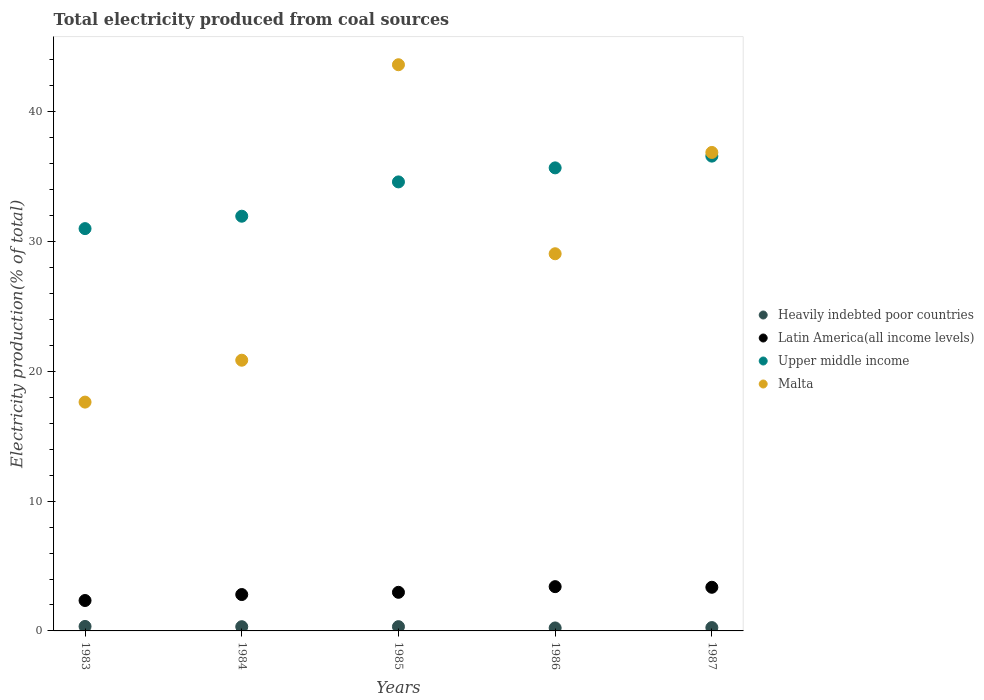Is the number of dotlines equal to the number of legend labels?
Keep it short and to the point. Yes. What is the total electricity produced in Latin America(all income levels) in 1984?
Provide a short and direct response. 2.8. Across all years, what is the maximum total electricity produced in Malta?
Keep it short and to the point. 43.62. Across all years, what is the minimum total electricity produced in Upper middle income?
Provide a short and direct response. 31. In which year was the total electricity produced in Heavily indebted poor countries minimum?
Give a very brief answer. 1986. What is the total total electricity produced in Latin America(all income levels) in the graph?
Ensure brevity in your answer.  14.9. What is the difference between the total electricity produced in Malta in 1984 and that in 1987?
Make the answer very short. -16.01. What is the difference between the total electricity produced in Malta in 1983 and the total electricity produced in Heavily indebted poor countries in 1986?
Make the answer very short. 17.4. What is the average total electricity produced in Malta per year?
Offer a very short reply. 29.61. In the year 1987, what is the difference between the total electricity produced in Upper middle income and total electricity produced in Heavily indebted poor countries?
Make the answer very short. 36.32. What is the ratio of the total electricity produced in Heavily indebted poor countries in 1983 to that in 1987?
Offer a very short reply. 1.34. What is the difference between the highest and the second highest total electricity produced in Latin America(all income levels)?
Your response must be concise. 0.05. What is the difference between the highest and the lowest total electricity produced in Latin America(all income levels)?
Ensure brevity in your answer.  1.07. In how many years, is the total electricity produced in Heavily indebted poor countries greater than the average total electricity produced in Heavily indebted poor countries taken over all years?
Provide a succinct answer. 3. Is the sum of the total electricity produced in Upper middle income in 1983 and 1986 greater than the maximum total electricity produced in Malta across all years?
Ensure brevity in your answer.  Yes. Is it the case that in every year, the sum of the total electricity produced in Latin America(all income levels) and total electricity produced in Upper middle income  is greater than the sum of total electricity produced in Heavily indebted poor countries and total electricity produced in Malta?
Make the answer very short. Yes. Is it the case that in every year, the sum of the total electricity produced in Upper middle income and total electricity produced in Heavily indebted poor countries  is greater than the total electricity produced in Malta?
Provide a succinct answer. No. Does the total electricity produced in Heavily indebted poor countries monotonically increase over the years?
Your answer should be very brief. No. How many dotlines are there?
Make the answer very short. 4. Are the values on the major ticks of Y-axis written in scientific E-notation?
Your answer should be compact. No. Does the graph contain grids?
Give a very brief answer. No. How many legend labels are there?
Make the answer very short. 4. What is the title of the graph?
Your answer should be compact. Total electricity produced from coal sources. Does "Korea (Democratic)" appear as one of the legend labels in the graph?
Offer a very short reply. No. What is the Electricity production(% of total) in Heavily indebted poor countries in 1983?
Your answer should be very brief. 0.34. What is the Electricity production(% of total) of Latin America(all income levels) in 1983?
Ensure brevity in your answer.  2.34. What is the Electricity production(% of total) of Upper middle income in 1983?
Offer a very short reply. 31. What is the Electricity production(% of total) of Malta in 1983?
Ensure brevity in your answer.  17.63. What is the Electricity production(% of total) of Heavily indebted poor countries in 1984?
Your answer should be compact. 0.33. What is the Electricity production(% of total) of Latin America(all income levels) in 1984?
Keep it short and to the point. 2.8. What is the Electricity production(% of total) in Upper middle income in 1984?
Give a very brief answer. 31.95. What is the Electricity production(% of total) in Malta in 1984?
Offer a very short reply. 20.86. What is the Electricity production(% of total) in Heavily indebted poor countries in 1985?
Offer a terse response. 0.33. What is the Electricity production(% of total) in Latin America(all income levels) in 1985?
Your answer should be very brief. 2.97. What is the Electricity production(% of total) in Upper middle income in 1985?
Make the answer very short. 34.6. What is the Electricity production(% of total) in Malta in 1985?
Offer a terse response. 43.62. What is the Electricity production(% of total) in Heavily indebted poor countries in 1986?
Make the answer very short. 0.23. What is the Electricity production(% of total) in Latin America(all income levels) in 1986?
Make the answer very short. 3.41. What is the Electricity production(% of total) in Upper middle income in 1986?
Your answer should be very brief. 35.68. What is the Electricity production(% of total) in Malta in 1986?
Make the answer very short. 29.06. What is the Electricity production(% of total) of Heavily indebted poor countries in 1987?
Offer a terse response. 0.26. What is the Electricity production(% of total) in Latin America(all income levels) in 1987?
Provide a short and direct response. 3.36. What is the Electricity production(% of total) of Upper middle income in 1987?
Offer a very short reply. 36.58. What is the Electricity production(% of total) of Malta in 1987?
Ensure brevity in your answer.  36.86. Across all years, what is the maximum Electricity production(% of total) in Heavily indebted poor countries?
Provide a succinct answer. 0.34. Across all years, what is the maximum Electricity production(% of total) of Latin America(all income levels)?
Your answer should be very brief. 3.41. Across all years, what is the maximum Electricity production(% of total) in Upper middle income?
Offer a terse response. 36.58. Across all years, what is the maximum Electricity production(% of total) in Malta?
Offer a terse response. 43.62. Across all years, what is the minimum Electricity production(% of total) of Heavily indebted poor countries?
Provide a succinct answer. 0.23. Across all years, what is the minimum Electricity production(% of total) in Latin America(all income levels)?
Your response must be concise. 2.34. Across all years, what is the minimum Electricity production(% of total) in Upper middle income?
Provide a short and direct response. 31. Across all years, what is the minimum Electricity production(% of total) in Malta?
Offer a very short reply. 17.63. What is the total Electricity production(% of total) of Heavily indebted poor countries in the graph?
Your answer should be compact. 1.49. What is the total Electricity production(% of total) in Latin America(all income levels) in the graph?
Provide a succinct answer. 14.9. What is the total Electricity production(% of total) in Upper middle income in the graph?
Your answer should be compact. 169.8. What is the total Electricity production(% of total) of Malta in the graph?
Provide a short and direct response. 148.03. What is the difference between the Electricity production(% of total) of Heavily indebted poor countries in 1983 and that in 1984?
Your answer should be very brief. 0.02. What is the difference between the Electricity production(% of total) in Latin America(all income levels) in 1983 and that in 1984?
Offer a very short reply. -0.46. What is the difference between the Electricity production(% of total) of Upper middle income in 1983 and that in 1984?
Provide a succinct answer. -0.96. What is the difference between the Electricity production(% of total) in Malta in 1983 and that in 1984?
Keep it short and to the point. -3.23. What is the difference between the Electricity production(% of total) in Heavily indebted poor countries in 1983 and that in 1985?
Ensure brevity in your answer.  0.02. What is the difference between the Electricity production(% of total) in Latin America(all income levels) in 1983 and that in 1985?
Your response must be concise. -0.63. What is the difference between the Electricity production(% of total) in Upper middle income in 1983 and that in 1985?
Keep it short and to the point. -3.6. What is the difference between the Electricity production(% of total) in Malta in 1983 and that in 1985?
Offer a very short reply. -25.99. What is the difference between the Electricity production(% of total) of Heavily indebted poor countries in 1983 and that in 1986?
Your answer should be very brief. 0.12. What is the difference between the Electricity production(% of total) in Latin America(all income levels) in 1983 and that in 1986?
Give a very brief answer. -1.07. What is the difference between the Electricity production(% of total) in Upper middle income in 1983 and that in 1986?
Offer a very short reply. -4.68. What is the difference between the Electricity production(% of total) of Malta in 1983 and that in 1986?
Offer a terse response. -11.43. What is the difference between the Electricity production(% of total) in Heavily indebted poor countries in 1983 and that in 1987?
Provide a succinct answer. 0.09. What is the difference between the Electricity production(% of total) in Latin America(all income levels) in 1983 and that in 1987?
Your answer should be very brief. -1.02. What is the difference between the Electricity production(% of total) of Upper middle income in 1983 and that in 1987?
Provide a short and direct response. -5.59. What is the difference between the Electricity production(% of total) in Malta in 1983 and that in 1987?
Give a very brief answer. -19.23. What is the difference between the Electricity production(% of total) in Heavily indebted poor countries in 1984 and that in 1985?
Your answer should be compact. -0. What is the difference between the Electricity production(% of total) in Latin America(all income levels) in 1984 and that in 1985?
Give a very brief answer. -0.17. What is the difference between the Electricity production(% of total) in Upper middle income in 1984 and that in 1985?
Your answer should be very brief. -2.64. What is the difference between the Electricity production(% of total) in Malta in 1984 and that in 1985?
Offer a very short reply. -22.77. What is the difference between the Electricity production(% of total) in Heavily indebted poor countries in 1984 and that in 1986?
Your response must be concise. 0.1. What is the difference between the Electricity production(% of total) in Latin America(all income levels) in 1984 and that in 1986?
Make the answer very short. -0.61. What is the difference between the Electricity production(% of total) of Upper middle income in 1984 and that in 1986?
Keep it short and to the point. -3.72. What is the difference between the Electricity production(% of total) of Malta in 1984 and that in 1986?
Give a very brief answer. -8.2. What is the difference between the Electricity production(% of total) of Heavily indebted poor countries in 1984 and that in 1987?
Your answer should be compact. 0.07. What is the difference between the Electricity production(% of total) of Latin America(all income levels) in 1984 and that in 1987?
Your answer should be compact. -0.56. What is the difference between the Electricity production(% of total) in Upper middle income in 1984 and that in 1987?
Your answer should be compact. -4.63. What is the difference between the Electricity production(% of total) of Malta in 1984 and that in 1987?
Give a very brief answer. -16.01. What is the difference between the Electricity production(% of total) of Heavily indebted poor countries in 1985 and that in 1986?
Make the answer very short. 0.1. What is the difference between the Electricity production(% of total) of Latin America(all income levels) in 1985 and that in 1986?
Your response must be concise. -0.44. What is the difference between the Electricity production(% of total) of Upper middle income in 1985 and that in 1986?
Provide a succinct answer. -1.08. What is the difference between the Electricity production(% of total) in Malta in 1985 and that in 1986?
Your response must be concise. 14.56. What is the difference between the Electricity production(% of total) in Heavily indebted poor countries in 1985 and that in 1987?
Make the answer very short. 0.07. What is the difference between the Electricity production(% of total) of Latin America(all income levels) in 1985 and that in 1987?
Keep it short and to the point. -0.39. What is the difference between the Electricity production(% of total) of Upper middle income in 1985 and that in 1987?
Your answer should be very brief. -1.99. What is the difference between the Electricity production(% of total) in Malta in 1985 and that in 1987?
Keep it short and to the point. 6.76. What is the difference between the Electricity production(% of total) of Heavily indebted poor countries in 1986 and that in 1987?
Give a very brief answer. -0.03. What is the difference between the Electricity production(% of total) in Latin America(all income levels) in 1986 and that in 1987?
Make the answer very short. 0.05. What is the difference between the Electricity production(% of total) in Upper middle income in 1986 and that in 1987?
Offer a very short reply. -0.91. What is the difference between the Electricity production(% of total) of Malta in 1986 and that in 1987?
Ensure brevity in your answer.  -7.81. What is the difference between the Electricity production(% of total) of Heavily indebted poor countries in 1983 and the Electricity production(% of total) of Latin America(all income levels) in 1984?
Offer a very short reply. -2.46. What is the difference between the Electricity production(% of total) of Heavily indebted poor countries in 1983 and the Electricity production(% of total) of Upper middle income in 1984?
Provide a short and direct response. -31.61. What is the difference between the Electricity production(% of total) of Heavily indebted poor countries in 1983 and the Electricity production(% of total) of Malta in 1984?
Make the answer very short. -20.51. What is the difference between the Electricity production(% of total) in Latin America(all income levels) in 1983 and the Electricity production(% of total) in Upper middle income in 1984?
Make the answer very short. -29.61. What is the difference between the Electricity production(% of total) of Latin America(all income levels) in 1983 and the Electricity production(% of total) of Malta in 1984?
Give a very brief answer. -18.51. What is the difference between the Electricity production(% of total) of Upper middle income in 1983 and the Electricity production(% of total) of Malta in 1984?
Ensure brevity in your answer.  10.14. What is the difference between the Electricity production(% of total) of Heavily indebted poor countries in 1983 and the Electricity production(% of total) of Latin America(all income levels) in 1985?
Your response must be concise. -2.63. What is the difference between the Electricity production(% of total) in Heavily indebted poor countries in 1983 and the Electricity production(% of total) in Upper middle income in 1985?
Provide a succinct answer. -34.25. What is the difference between the Electricity production(% of total) in Heavily indebted poor countries in 1983 and the Electricity production(% of total) in Malta in 1985?
Offer a very short reply. -43.28. What is the difference between the Electricity production(% of total) in Latin America(all income levels) in 1983 and the Electricity production(% of total) in Upper middle income in 1985?
Give a very brief answer. -32.25. What is the difference between the Electricity production(% of total) in Latin America(all income levels) in 1983 and the Electricity production(% of total) in Malta in 1985?
Give a very brief answer. -41.28. What is the difference between the Electricity production(% of total) of Upper middle income in 1983 and the Electricity production(% of total) of Malta in 1985?
Offer a very short reply. -12.63. What is the difference between the Electricity production(% of total) of Heavily indebted poor countries in 1983 and the Electricity production(% of total) of Latin America(all income levels) in 1986?
Offer a terse response. -3.07. What is the difference between the Electricity production(% of total) in Heavily indebted poor countries in 1983 and the Electricity production(% of total) in Upper middle income in 1986?
Make the answer very short. -35.33. What is the difference between the Electricity production(% of total) of Heavily indebted poor countries in 1983 and the Electricity production(% of total) of Malta in 1986?
Your response must be concise. -28.71. What is the difference between the Electricity production(% of total) of Latin America(all income levels) in 1983 and the Electricity production(% of total) of Upper middle income in 1986?
Ensure brevity in your answer.  -33.33. What is the difference between the Electricity production(% of total) of Latin America(all income levels) in 1983 and the Electricity production(% of total) of Malta in 1986?
Make the answer very short. -26.72. What is the difference between the Electricity production(% of total) in Upper middle income in 1983 and the Electricity production(% of total) in Malta in 1986?
Offer a very short reply. 1.94. What is the difference between the Electricity production(% of total) in Heavily indebted poor countries in 1983 and the Electricity production(% of total) in Latin America(all income levels) in 1987?
Offer a terse response. -3.02. What is the difference between the Electricity production(% of total) of Heavily indebted poor countries in 1983 and the Electricity production(% of total) of Upper middle income in 1987?
Provide a succinct answer. -36.24. What is the difference between the Electricity production(% of total) in Heavily indebted poor countries in 1983 and the Electricity production(% of total) in Malta in 1987?
Your answer should be very brief. -36.52. What is the difference between the Electricity production(% of total) in Latin America(all income levels) in 1983 and the Electricity production(% of total) in Upper middle income in 1987?
Your answer should be very brief. -34.24. What is the difference between the Electricity production(% of total) of Latin America(all income levels) in 1983 and the Electricity production(% of total) of Malta in 1987?
Make the answer very short. -34.52. What is the difference between the Electricity production(% of total) of Upper middle income in 1983 and the Electricity production(% of total) of Malta in 1987?
Make the answer very short. -5.87. What is the difference between the Electricity production(% of total) of Heavily indebted poor countries in 1984 and the Electricity production(% of total) of Latin America(all income levels) in 1985?
Keep it short and to the point. -2.65. What is the difference between the Electricity production(% of total) of Heavily indebted poor countries in 1984 and the Electricity production(% of total) of Upper middle income in 1985?
Provide a succinct answer. -34.27. What is the difference between the Electricity production(% of total) of Heavily indebted poor countries in 1984 and the Electricity production(% of total) of Malta in 1985?
Provide a succinct answer. -43.3. What is the difference between the Electricity production(% of total) of Latin America(all income levels) in 1984 and the Electricity production(% of total) of Upper middle income in 1985?
Offer a very short reply. -31.79. What is the difference between the Electricity production(% of total) of Latin America(all income levels) in 1984 and the Electricity production(% of total) of Malta in 1985?
Your answer should be very brief. -40.82. What is the difference between the Electricity production(% of total) in Upper middle income in 1984 and the Electricity production(% of total) in Malta in 1985?
Give a very brief answer. -11.67. What is the difference between the Electricity production(% of total) of Heavily indebted poor countries in 1984 and the Electricity production(% of total) of Latin America(all income levels) in 1986?
Provide a short and direct response. -3.09. What is the difference between the Electricity production(% of total) in Heavily indebted poor countries in 1984 and the Electricity production(% of total) in Upper middle income in 1986?
Your answer should be compact. -35.35. What is the difference between the Electricity production(% of total) in Heavily indebted poor countries in 1984 and the Electricity production(% of total) in Malta in 1986?
Your answer should be very brief. -28.73. What is the difference between the Electricity production(% of total) of Latin America(all income levels) in 1984 and the Electricity production(% of total) of Upper middle income in 1986?
Keep it short and to the point. -32.87. What is the difference between the Electricity production(% of total) in Latin America(all income levels) in 1984 and the Electricity production(% of total) in Malta in 1986?
Make the answer very short. -26.26. What is the difference between the Electricity production(% of total) in Upper middle income in 1984 and the Electricity production(% of total) in Malta in 1986?
Give a very brief answer. 2.89. What is the difference between the Electricity production(% of total) of Heavily indebted poor countries in 1984 and the Electricity production(% of total) of Latin America(all income levels) in 1987?
Ensure brevity in your answer.  -3.04. What is the difference between the Electricity production(% of total) in Heavily indebted poor countries in 1984 and the Electricity production(% of total) in Upper middle income in 1987?
Your answer should be compact. -36.26. What is the difference between the Electricity production(% of total) of Heavily indebted poor countries in 1984 and the Electricity production(% of total) of Malta in 1987?
Keep it short and to the point. -36.54. What is the difference between the Electricity production(% of total) of Latin America(all income levels) in 1984 and the Electricity production(% of total) of Upper middle income in 1987?
Your response must be concise. -33.78. What is the difference between the Electricity production(% of total) of Latin America(all income levels) in 1984 and the Electricity production(% of total) of Malta in 1987?
Keep it short and to the point. -34.06. What is the difference between the Electricity production(% of total) of Upper middle income in 1984 and the Electricity production(% of total) of Malta in 1987?
Make the answer very short. -4.91. What is the difference between the Electricity production(% of total) of Heavily indebted poor countries in 1985 and the Electricity production(% of total) of Latin America(all income levels) in 1986?
Keep it short and to the point. -3.08. What is the difference between the Electricity production(% of total) in Heavily indebted poor countries in 1985 and the Electricity production(% of total) in Upper middle income in 1986?
Provide a succinct answer. -35.35. What is the difference between the Electricity production(% of total) of Heavily indebted poor countries in 1985 and the Electricity production(% of total) of Malta in 1986?
Keep it short and to the point. -28.73. What is the difference between the Electricity production(% of total) of Latin America(all income levels) in 1985 and the Electricity production(% of total) of Upper middle income in 1986?
Give a very brief answer. -32.7. What is the difference between the Electricity production(% of total) in Latin America(all income levels) in 1985 and the Electricity production(% of total) in Malta in 1986?
Your answer should be compact. -26.08. What is the difference between the Electricity production(% of total) in Upper middle income in 1985 and the Electricity production(% of total) in Malta in 1986?
Provide a succinct answer. 5.54. What is the difference between the Electricity production(% of total) of Heavily indebted poor countries in 1985 and the Electricity production(% of total) of Latin America(all income levels) in 1987?
Make the answer very short. -3.03. What is the difference between the Electricity production(% of total) in Heavily indebted poor countries in 1985 and the Electricity production(% of total) in Upper middle income in 1987?
Your response must be concise. -36.25. What is the difference between the Electricity production(% of total) in Heavily indebted poor countries in 1985 and the Electricity production(% of total) in Malta in 1987?
Keep it short and to the point. -36.54. What is the difference between the Electricity production(% of total) in Latin America(all income levels) in 1985 and the Electricity production(% of total) in Upper middle income in 1987?
Your answer should be compact. -33.61. What is the difference between the Electricity production(% of total) in Latin America(all income levels) in 1985 and the Electricity production(% of total) in Malta in 1987?
Provide a short and direct response. -33.89. What is the difference between the Electricity production(% of total) in Upper middle income in 1985 and the Electricity production(% of total) in Malta in 1987?
Offer a very short reply. -2.27. What is the difference between the Electricity production(% of total) of Heavily indebted poor countries in 1986 and the Electricity production(% of total) of Latin America(all income levels) in 1987?
Provide a short and direct response. -3.13. What is the difference between the Electricity production(% of total) in Heavily indebted poor countries in 1986 and the Electricity production(% of total) in Upper middle income in 1987?
Offer a terse response. -36.35. What is the difference between the Electricity production(% of total) in Heavily indebted poor countries in 1986 and the Electricity production(% of total) in Malta in 1987?
Your answer should be compact. -36.64. What is the difference between the Electricity production(% of total) of Latin America(all income levels) in 1986 and the Electricity production(% of total) of Upper middle income in 1987?
Your answer should be very brief. -33.17. What is the difference between the Electricity production(% of total) of Latin America(all income levels) in 1986 and the Electricity production(% of total) of Malta in 1987?
Your answer should be very brief. -33.45. What is the difference between the Electricity production(% of total) in Upper middle income in 1986 and the Electricity production(% of total) in Malta in 1987?
Provide a succinct answer. -1.19. What is the average Electricity production(% of total) in Heavily indebted poor countries per year?
Offer a very short reply. 0.3. What is the average Electricity production(% of total) of Latin America(all income levels) per year?
Offer a terse response. 2.98. What is the average Electricity production(% of total) of Upper middle income per year?
Your answer should be very brief. 33.96. What is the average Electricity production(% of total) of Malta per year?
Ensure brevity in your answer.  29.61. In the year 1983, what is the difference between the Electricity production(% of total) of Heavily indebted poor countries and Electricity production(% of total) of Latin America(all income levels)?
Ensure brevity in your answer.  -2. In the year 1983, what is the difference between the Electricity production(% of total) of Heavily indebted poor countries and Electricity production(% of total) of Upper middle income?
Ensure brevity in your answer.  -30.65. In the year 1983, what is the difference between the Electricity production(% of total) of Heavily indebted poor countries and Electricity production(% of total) of Malta?
Give a very brief answer. -17.28. In the year 1983, what is the difference between the Electricity production(% of total) of Latin America(all income levels) and Electricity production(% of total) of Upper middle income?
Provide a succinct answer. -28.65. In the year 1983, what is the difference between the Electricity production(% of total) of Latin America(all income levels) and Electricity production(% of total) of Malta?
Your answer should be compact. -15.29. In the year 1983, what is the difference between the Electricity production(% of total) of Upper middle income and Electricity production(% of total) of Malta?
Offer a very short reply. 13.37. In the year 1984, what is the difference between the Electricity production(% of total) in Heavily indebted poor countries and Electricity production(% of total) in Latin America(all income levels)?
Your answer should be compact. -2.48. In the year 1984, what is the difference between the Electricity production(% of total) in Heavily indebted poor countries and Electricity production(% of total) in Upper middle income?
Your answer should be compact. -31.63. In the year 1984, what is the difference between the Electricity production(% of total) of Heavily indebted poor countries and Electricity production(% of total) of Malta?
Provide a short and direct response. -20.53. In the year 1984, what is the difference between the Electricity production(% of total) in Latin America(all income levels) and Electricity production(% of total) in Upper middle income?
Provide a short and direct response. -29.15. In the year 1984, what is the difference between the Electricity production(% of total) in Latin America(all income levels) and Electricity production(% of total) in Malta?
Your answer should be very brief. -18.05. In the year 1984, what is the difference between the Electricity production(% of total) of Upper middle income and Electricity production(% of total) of Malta?
Your answer should be very brief. 11.09. In the year 1985, what is the difference between the Electricity production(% of total) of Heavily indebted poor countries and Electricity production(% of total) of Latin America(all income levels)?
Keep it short and to the point. -2.65. In the year 1985, what is the difference between the Electricity production(% of total) of Heavily indebted poor countries and Electricity production(% of total) of Upper middle income?
Your response must be concise. -34.27. In the year 1985, what is the difference between the Electricity production(% of total) in Heavily indebted poor countries and Electricity production(% of total) in Malta?
Your response must be concise. -43.29. In the year 1985, what is the difference between the Electricity production(% of total) in Latin America(all income levels) and Electricity production(% of total) in Upper middle income?
Your answer should be very brief. -31.62. In the year 1985, what is the difference between the Electricity production(% of total) of Latin America(all income levels) and Electricity production(% of total) of Malta?
Provide a succinct answer. -40.65. In the year 1985, what is the difference between the Electricity production(% of total) of Upper middle income and Electricity production(% of total) of Malta?
Make the answer very short. -9.03. In the year 1986, what is the difference between the Electricity production(% of total) of Heavily indebted poor countries and Electricity production(% of total) of Latin America(all income levels)?
Provide a short and direct response. -3.18. In the year 1986, what is the difference between the Electricity production(% of total) in Heavily indebted poor countries and Electricity production(% of total) in Upper middle income?
Offer a very short reply. -35.45. In the year 1986, what is the difference between the Electricity production(% of total) in Heavily indebted poor countries and Electricity production(% of total) in Malta?
Your response must be concise. -28.83. In the year 1986, what is the difference between the Electricity production(% of total) in Latin America(all income levels) and Electricity production(% of total) in Upper middle income?
Ensure brevity in your answer.  -32.27. In the year 1986, what is the difference between the Electricity production(% of total) in Latin America(all income levels) and Electricity production(% of total) in Malta?
Provide a short and direct response. -25.65. In the year 1986, what is the difference between the Electricity production(% of total) in Upper middle income and Electricity production(% of total) in Malta?
Offer a terse response. 6.62. In the year 1987, what is the difference between the Electricity production(% of total) in Heavily indebted poor countries and Electricity production(% of total) in Latin America(all income levels)?
Offer a very short reply. -3.1. In the year 1987, what is the difference between the Electricity production(% of total) in Heavily indebted poor countries and Electricity production(% of total) in Upper middle income?
Make the answer very short. -36.32. In the year 1987, what is the difference between the Electricity production(% of total) in Heavily indebted poor countries and Electricity production(% of total) in Malta?
Provide a succinct answer. -36.61. In the year 1987, what is the difference between the Electricity production(% of total) of Latin America(all income levels) and Electricity production(% of total) of Upper middle income?
Keep it short and to the point. -33.22. In the year 1987, what is the difference between the Electricity production(% of total) of Latin America(all income levels) and Electricity production(% of total) of Malta?
Offer a terse response. -33.5. In the year 1987, what is the difference between the Electricity production(% of total) of Upper middle income and Electricity production(% of total) of Malta?
Make the answer very short. -0.28. What is the ratio of the Electricity production(% of total) of Heavily indebted poor countries in 1983 to that in 1984?
Offer a terse response. 1.06. What is the ratio of the Electricity production(% of total) of Latin America(all income levels) in 1983 to that in 1984?
Your answer should be very brief. 0.84. What is the ratio of the Electricity production(% of total) in Upper middle income in 1983 to that in 1984?
Keep it short and to the point. 0.97. What is the ratio of the Electricity production(% of total) in Malta in 1983 to that in 1984?
Provide a short and direct response. 0.85. What is the ratio of the Electricity production(% of total) of Heavily indebted poor countries in 1983 to that in 1985?
Offer a very short reply. 1.05. What is the ratio of the Electricity production(% of total) of Latin America(all income levels) in 1983 to that in 1985?
Provide a succinct answer. 0.79. What is the ratio of the Electricity production(% of total) in Upper middle income in 1983 to that in 1985?
Your answer should be compact. 0.9. What is the ratio of the Electricity production(% of total) of Malta in 1983 to that in 1985?
Keep it short and to the point. 0.4. What is the ratio of the Electricity production(% of total) in Heavily indebted poor countries in 1983 to that in 1986?
Offer a terse response. 1.51. What is the ratio of the Electricity production(% of total) of Latin America(all income levels) in 1983 to that in 1986?
Provide a succinct answer. 0.69. What is the ratio of the Electricity production(% of total) in Upper middle income in 1983 to that in 1986?
Offer a very short reply. 0.87. What is the ratio of the Electricity production(% of total) of Malta in 1983 to that in 1986?
Your answer should be very brief. 0.61. What is the ratio of the Electricity production(% of total) of Heavily indebted poor countries in 1983 to that in 1987?
Offer a very short reply. 1.34. What is the ratio of the Electricity production(% of total) in Latin America(all income levels) in 1983 to that in 1987?
Ensure brevity in your answer.  0.7. What is the ratio of the Electricity production(% of total) of Upper middle income in 1983 to that in 1987?
Your answer should be compact. 0.85. What is the ratio of the Electricity production(% of total) of Malta in 1983 to that in 1987?
Your answer should be very brief. 0.48. What is the ratio of the Electricity production(% of total) in Heavily indebted poor countries in 1984 to that in 1985?
Keep it short and to the point. 0.99. What is the ratio of the Electricity production(% of total) in Latin America(all income levels) in 1984 to that in 1985?
Give a very brief answer. 0.94. What is the ratio of the Electricity production(% of total) of Upper middle income in 1984 to that in 1985?
Ensure brevity in your answer.  0.92. What is the ratio of the Electricity production(% of total) in Malta in 1984 to that in 1985?
Offer a very short reply. 0.48. What is the ratio of the Electricity production(% of total) in Heavily indebted poor countries in 1984 to that in 1986?
Offer a terse response. 1.42. What is the ratio of the Electricity production(% of total) in Latin America(all income levels) in 1984 to that in 1986?
Ensure brevity in your answer.  0.82. What is the ratio of the Electricity production(% of total) of Upper middle income in 1984 to that in 1986?
Provide a short and direct response. 0.9. What is the ratio of the Electricity production(% of total) in Malta in 1984 to that in 1986?
Offer a very short reply. 0.72. What is the ratio of the Electricity production(% of total) of Heavily indebted poor countries in 1984 to that in 1987?
Provide a succinct answer. 1.26. What is the ratio of the Electricity production(% of total) of Latin America(all income levels) in 1984 to that in 1987?
Offer a very short reply. 0.83. What is the ratio of the Electricity production(% of total) of Upper middle income in 1984 to that in 1987?
Your answer should be compact. 0.87. What is the ratio of the Electricity production(% of total) in Malta in 1984 to that in 1987?
Offer a terse response. 0.57. What is the ratio of the Electricity production(% of total) of Heavily indebted poor countries in 1985 to that in 1986?
Your answer should be compact. 1.43. What is the ratio of the Electricity production(% of total) of Latin America(all income levels) in 1985 to that in 1986?
Your answer should be very brief. 0.87. What is the ratio of the Electricity production(% of total) in Upper middle income in 1985 to that in 1986?
Your answer should be very brief. 0.97. What is the ratio of the Electricity production(% of total) in Malta in 1985 to that in 1986?
Your response must be concise. 1.5. What is the ratio of the Electricity production(% of total) of Heavily indebted poor countries in 1985 to that in 1987?
Give a very brief answer. 1.27. What is the ratio of the Electricity production(% of total) of Latin America(all income levels) in 1985 to that in 1987?
Your response must be concise. 0.88. What is the ratio of the Electricity production(% of total) in Upper middle income in 1985 to that in 1987?
Provide a short and direct response. 0.95. What is the ratio of the Electricity production(% of total) in Malta in 1985 to that in 1987?
Keep it short and to the point. 1.18. What is the ratio of the Electricity production(% of total) of Heavily indebted poor countries in 1986 to that in 1987?
Keep it short and to the point. 0.89. What is the ratio of the Electricity production(% of total) in Latin America(all income levels) in 1986 to that in 1987?
Offer a very short reply. 1.01. What is the ratio of the Electricity production(% of total) in Upper middle income in 1986 to that in 1987?
Provide a succinct answer. 0.98. What is the ratio of the Electricity production(% of total) of Malta in 1986 to that in 1987?
Give a very brief answer. 0.79. What is the difference between the highest and the second highest Electricity production(% of total) in Heavily indebted poor countries?
Give a very brief answer. 0.02. What is the difference between the highest and the second highest Electricity production(% of total) of Latin America(all income levels)?
Keep it short and to the point. 0.05. What is the difference between the highest and the second highest Electricity production(% of total) of Upper middle income?
Your answer should be very brief. 0.91. What is the difference between the highest and the second highest Electricity production(% of total) in Malta?
Your answer should be compact. 6.76. What is the difference between the highest and the lowest Electricity production(% of total) in Heavily indebted poor countries?
Offer a very short reply. 0.12. What is the difference between the highest and the lowest Electricity production(% of total) of Latin America(all income levels)?
Provide a short and direct response. 1.07. What is the difference between the highest and the lowest Electricity production(% of total) of Upper middle income?
Your answer should be compact. 5.59. What is the difference between the highest and the lowest Electricity production(% of total) in Malta?
Your answer should be very brief. 25.99. 